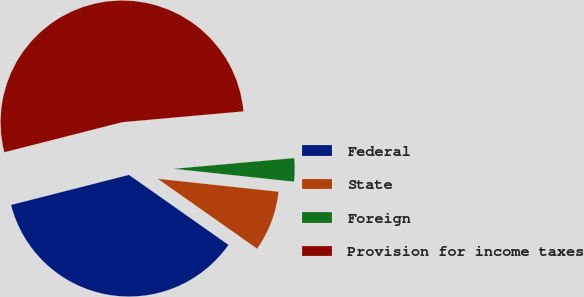Convert chart to OTSL. <chart><loc_0><loc_0><loc_500><loc_500><pie_chart><fcel>Federal<fcel>State<fcel>Foreign<fcel>Provision for income taxes<nl><fcel>36.27%<fcel>8.06%<fcel>3.11%<fcel>52.56%<nl></chart> 